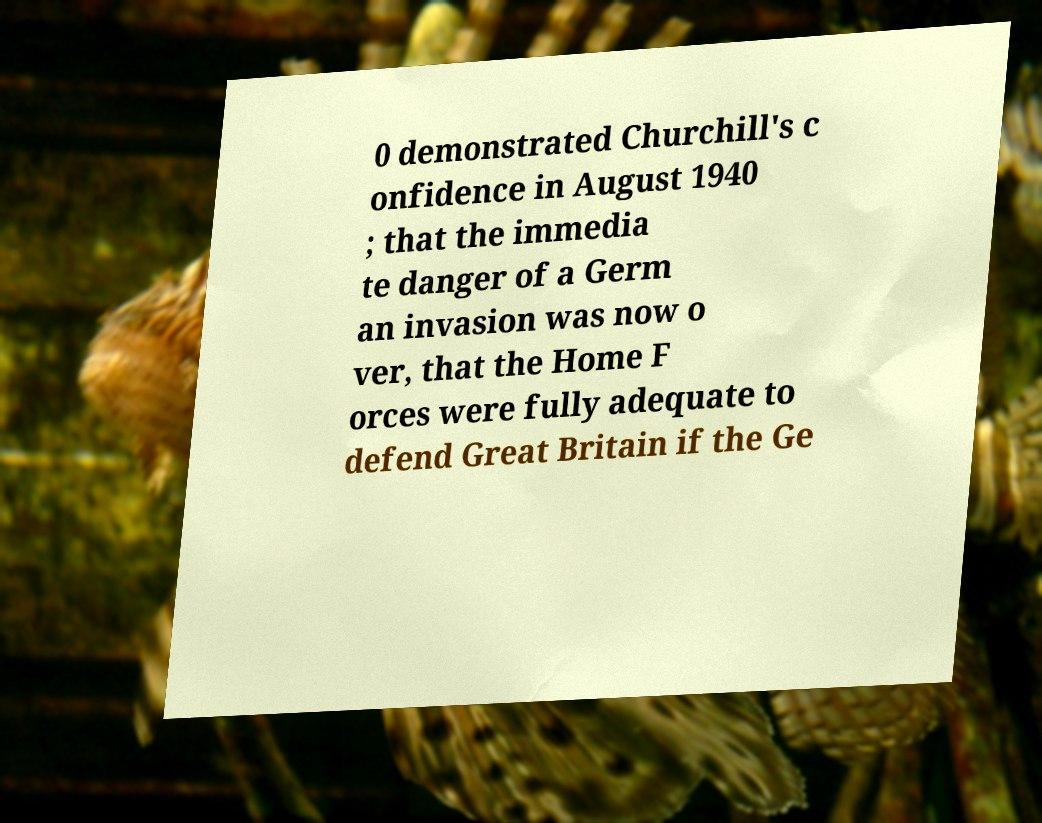Could you extract and type out the text from this image? 0 demonstrated Churchill's c onfidence in August 1940 ; that the immedia te danger of a Germ an invasion was now o ver, that the Home F orces were fully adequate to defend Great Britain if the Ge 